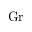Convert formula to latex. <formula><loc_0><loc_0><loc_500><loc_500>G r</formula> 